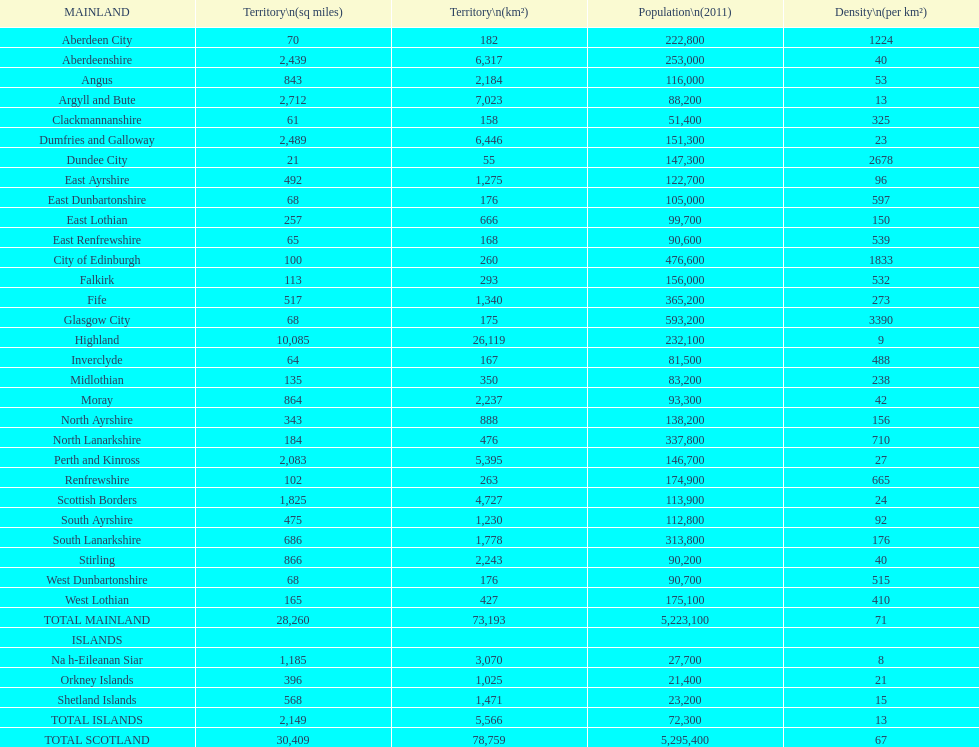What is the average population density in mainland cities? 71. 